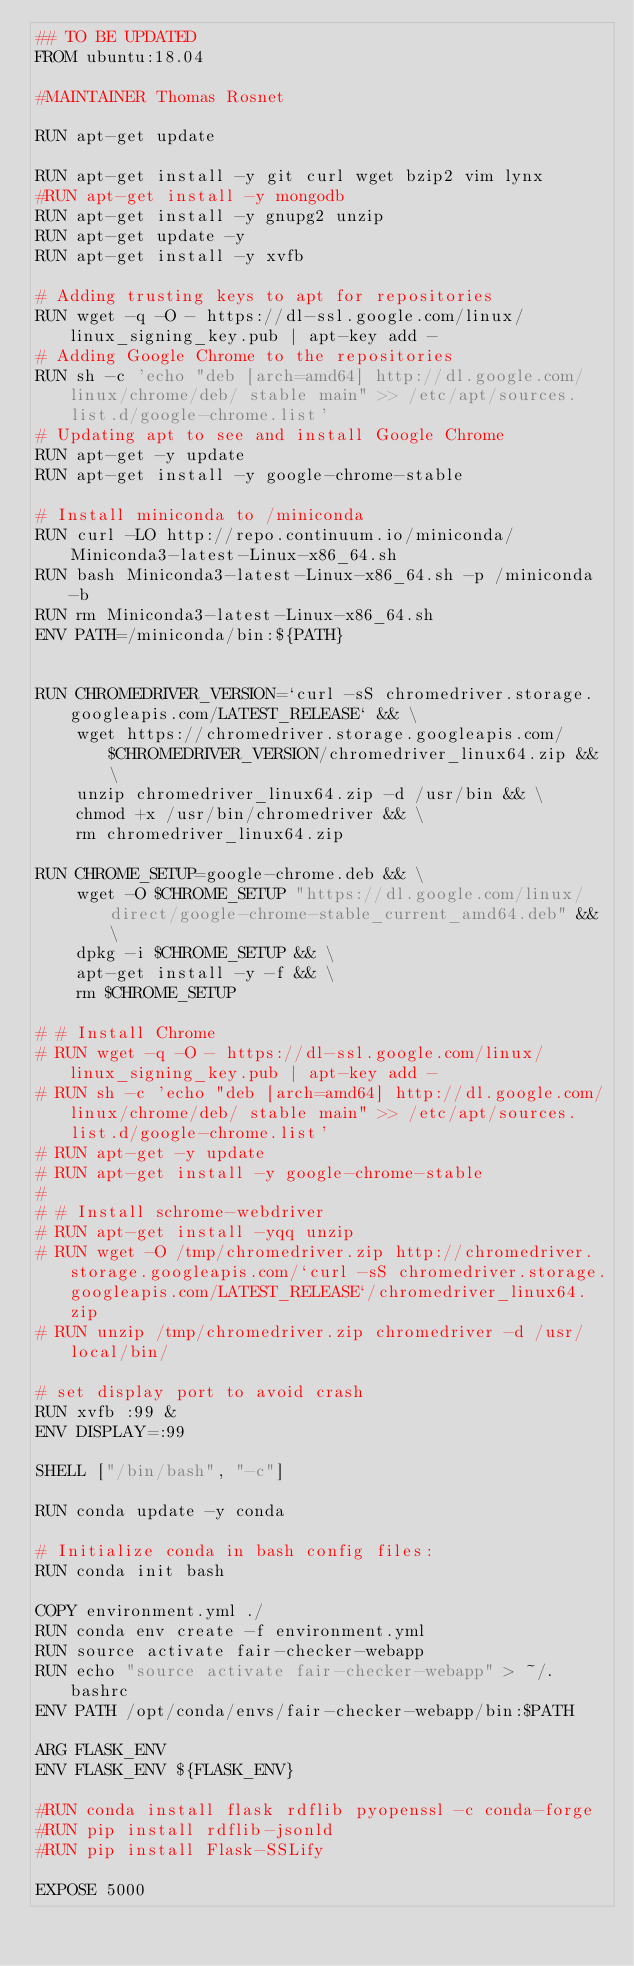Convert code to text. <code><loc_0><loc_0><loc_500><loc_500><_Dockerfile_>## TO BE UPDATED
FROM ubuntu:18.04

#MAINTAINER Thomas Rosnet

RUN apt-get update

RUN apt-get install -y git curl wget bzip2 vim lynx
#RUN apt-get install -y mongodb
RUN apt-get install -y gnupg2 unzip
RUN apt-get update -y
RUN apt-get install -y xvfb

# Adding trusting keys to apt for repositories
RUN wget -q -O - https://dl-ssl.google.com/linux/linux_signing_key.pub | apt-key add -
# Adding Google Chrome to the repositories
RUN sh -c 'echo "deb [arch=amd64] http://dl.google.com/linux/chrome/deb/ stable main" >> /etc/apt/sources.list.d/google-chrome.list'
# Updating apt to see and install Google Chrome
RUN apt-get -y update
RUN apt-get install -y google-chrome-stable

# Install miniconda to /miniconda
RUN curl -LO http://repo.continuum.io/miniconda/Miniconda3-latest-Linux-x86_64.sh
RUN bash Miniconda3-latest-Linux-x86_64.sh -p /miniconda -b
RUN rm Miniconda3-latest-Linux-x86_64.sh
ENV PATH=/miniconda/bin:${PATH}


RUN CHROMEDRIVER_VERSION=`curl -sS chromedriver.storage.googleapis.com/LATEST_RELEASE` && \
    wget https://chromedriver.storage.googleapis.com/$CHROMEDRIVER_VERSION/chromedriver_linux64.zip && \
    unzip chromedriver_linux64.zip -d /usr/bin && \
    chmod +x /usr/bin/chromedriver && \
    rm chromedriver_linux64.zip

RUN CHROME_SETUP=google-chrome.deb && \
    wget -O $CHROME_SETUP "https://dl.google.com/linux/direct/google-chrome-stable_current_amd64.deb" && \
    dpkg -i $CHROME_SETUP && \
    apt-get install -y -f && \
    rm $CHROME_SETUP

# # Install Chrome
# RUN wget -q -O - https://dl-ssl.google.com/linux/linux_signing_key.pub | apt-key add -
# RUN sh -c 'echo "deb [arch=amd64] http://dl.google.com/linux/chrome/deb/ stable main" >> /etc/apt/sources.list.d/google-chrome.list'
# RUN apt-get -y update
# RUN apt-get install -y google-chrome-stable
#
# # Install schrome-webdriver
# RUN apt-get install -yqq unzip
# RUN wget -O /tmp/chromedriver.zip http://chromedriver.storage.googleapis.com/`curl -sS chromedriver.storage.googleapis.com/LATEST_RELEASE`/chromedriver_linux64.zip
# RUN unzip /tmp/chromedriver.zip chromedriver -d /usr/local/bin/

# set display port to avoid crash
RUN xvfb :99 &
ENV DISPLAY=:99

SHELL ["/bin/bash", "-c"]

RUN conda update -y conda

# Initialize conda in bash config files:
RUN conda init bash

COPY environment.yml ./
RUN conda env create -f environment.yml
RUN source activate fair-checker-webapp
RUN echo "source activate fair-checker-webapp" > ~/.bashrc
ENV PATH /opt/conda/envs/fair-checker-webapp/bin:$PATH

ARG FLASK_ENV
ENV FLASK_ENV ${FLASK_ENV}

#RUN conda install flask rdflib pyopenssl -c conda-forge
#RUN pip install rdflib-jsonld
#RUN pip install Flask-SSLify

EXPOSE 5000
</code> 